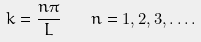<formula> <loc_0><loc_0><loc_500><loc_500>k = { \frac { n \pi } { L } } \quad n = 1 , 2 , 3 , \dots .</formula> 